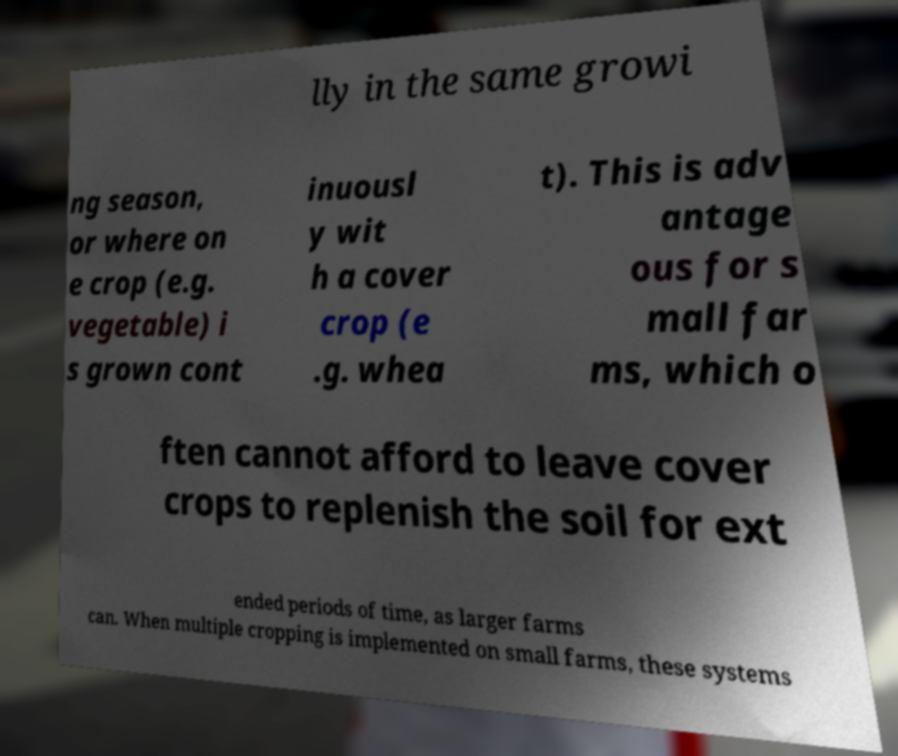For documentation purposes, I need the text within this image transcribed. Could you provide that? lly in the same growi ng season, or where on e crop (e.g. vegetable) i s grown cont inuousl y wit h a cover crop (e .g. whea t). This is adv antage ous for s mall far ms, which o ften cannot afford to leave cover crops to replenish the soil for ext ended periods of time, as larger farms can. When multiple cropping is implemented on small farms, these systems 